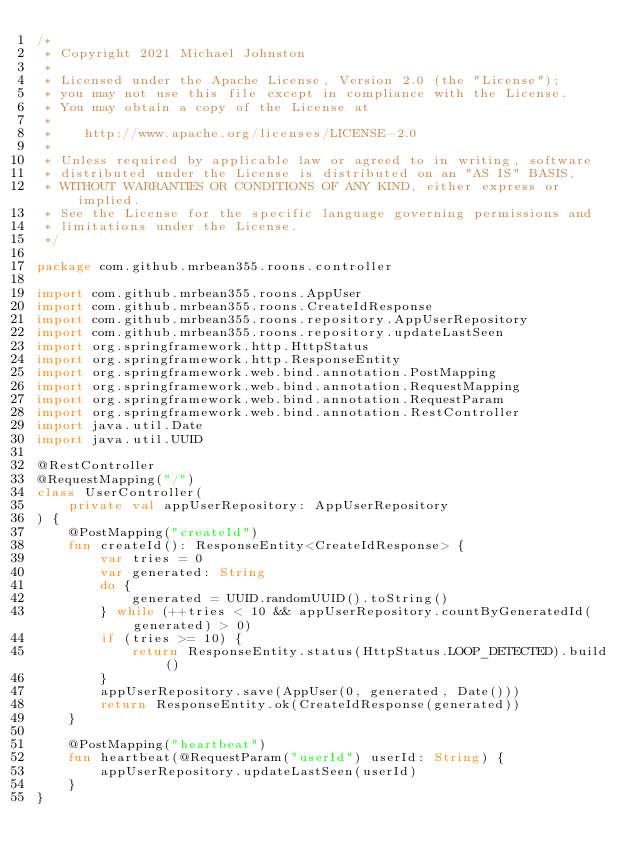<code> <loc_0><loc_0><loc_500><loc_500><_Kotlin_>/*
 * Copyright 2021 Michael Johnston
 *
 * Licensed under the Apache License, Version 2.0 (the "License");
 * you may not use this file except in compliance with the License.
 * You may obtain a copy of the License at
 *
 *    http://www.apache.org/licenses/LICENSE-2.0
 *
 * Unless required by applicable law or agreed to in writing, software
 * distributed under the License is distributed on an "AS IS" BASIS,
 * WITHOUT WARRANTIES OR CONDITIONS OF ANY KIND, either express or implied.
 * See the License for the specific language governing permissions and
 * limitations under the License.
 */

package com.github.mrbean355.roons.controller

import com.github.mrbean355.roons.AppUser
import com.github.mrbean355.roons.CreateIdResponse
import com.github.mrbean355.roons.repository.AppUserRepository
import com.github.mrbean355.roons.repository.updateLastSeen
import org.springframework.http.HttpStatus
import org.springframework.http.ResponseEntity
import org.springframework.web.bind.annotation.PostMapping
import org.springframework.web.bind.annotation.RequestMapping
import org.springframework.web.bind.annotation.RequestParam
import org.springframework.web.bind.annotation.RestController
import java.util.Date
import java.util.UUID

@RestController
@RequestMapping("/")
class UserController(
    private val appUserRepository: AppUserRepository
) {
    @PostMapping("createId")
    fun createId(): ResponseEntity<CreateIdResponse> {
        var tries = 0
        var generated: String
        do {
            generated = UUID.randomUUID().toString()
        } while (++tries < 10 && appUserRepository.countByGeneratedId(generated) > 0)
        if (tries >= 10) {
            return ResponseEntity.status(HttpStatus.LOOP_DETECTED).build()
        }
        appUserRepository.save(AppUser(0, generated, Date()))
        return ResponseEntity.ok(CreateIdResponse(generated))
    }

    @PostMapping("heartbeat")
    fun heartbeat(@RequestParam("userId") userId: String) {
        appUserRepository.updateLastSeen(userId)
    }
}</code> 